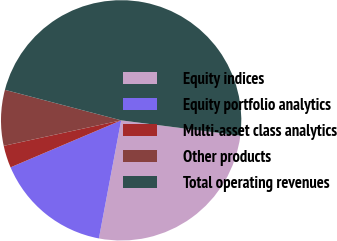Convert chart to OTSL. <chart><loc_0><loc_0><loc_500><loc_500><pie_chart><fcel>Equity indices<fcel>Equity portfolio analytics<fcel>Multi-asset class analytics<fcel>Other products<fcel>Total operating revenues<nl><fcel>25.93%<fcel>15.64%<fcel>2.99%<fcel>7.49%<fcel>47.95%<nl></chart> 